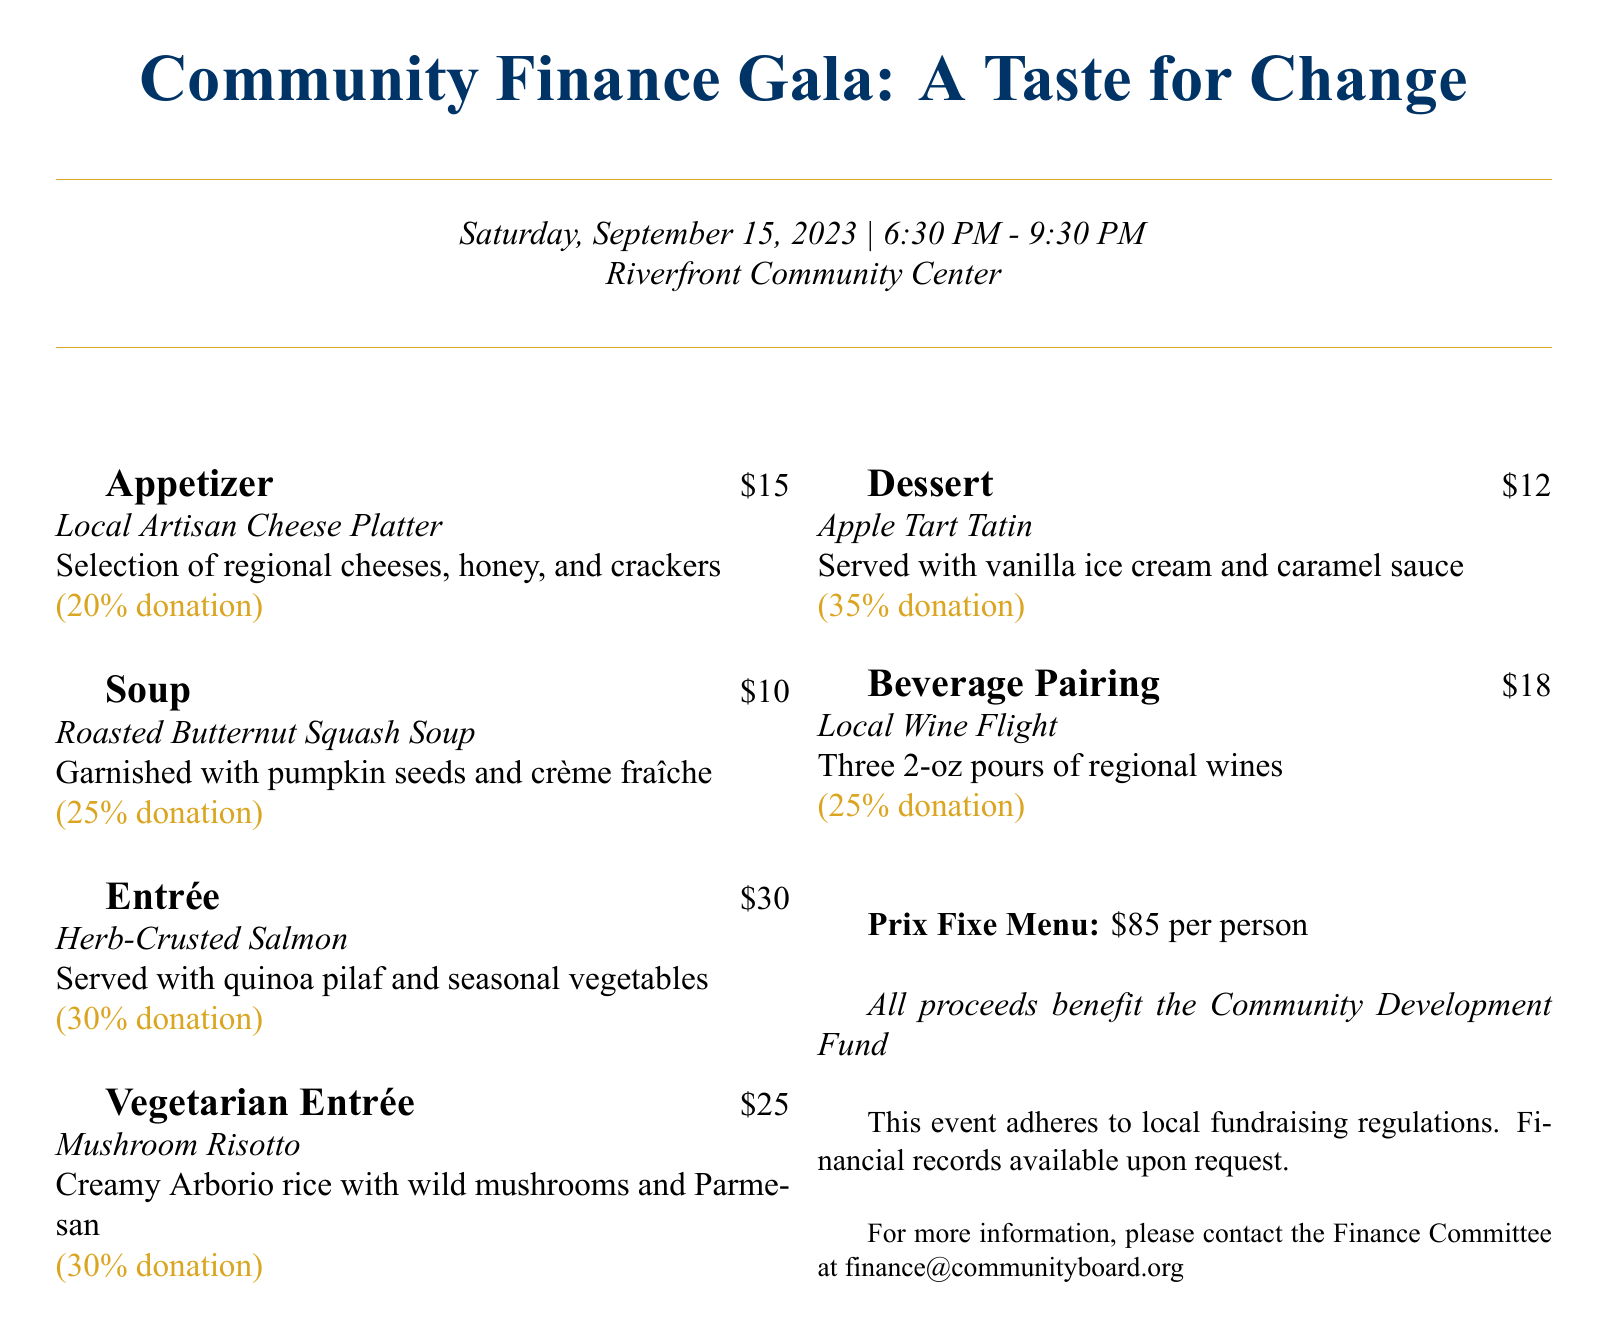what is the date of the event? The event is scheduled for Saturday, September 15, 2023.
Answer: September 15, 2023 how much does the prix fixe menu cost? The prix fixe menu is listed at $85 per person.
Answer: $85 what percentage of the appetizer's price is donated? The donation percentage for the Local Artisan Cheese Platter is indicated as 20%.
Answer: 20% what is the name of the vegetarian entrée? The vegetarian entrée listed is Mushroom Risotto.
Answer: Mushroom Risotto how much is the local wine flight? The Local Wine Flight is priced at $18.
Answer: $18 what is the total donation percentage for dessert? The Apple Tart Tatin's donation percentage is labeled as 35%.
Answer: 35% how many different courses are offered in the prix fixe menu? The menu includes five different courses: appetizer, soup, entrée, vegetarian entrée, and dessert.
Answer: Five who should be contacted for more information? The contact for more information is the Finance Committee at the provided email.
Answer: Finance Committee which dish has the highest donation percentage? The dish with the highest donation percentage is the Apple Tart Tatin at 35%.
Answer: Apple Tart Tatin 